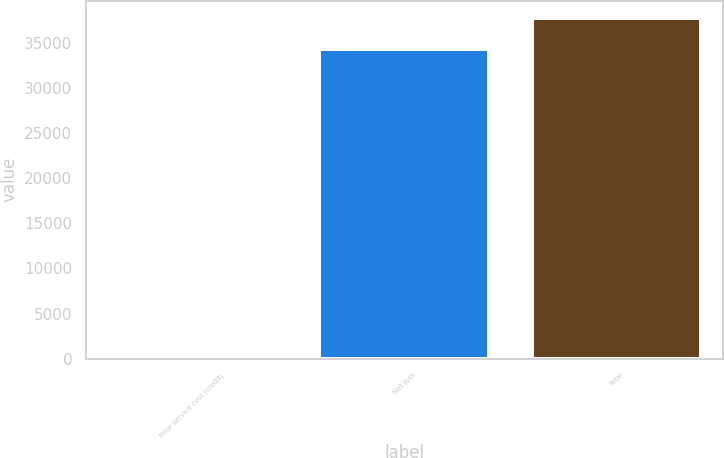<chart> <loc_0><loc_0><loc_500><loc_500><bar_chart><fcel>Prior service cost (credit)<fcel>Net loss<fcel>Total<nl><fcel>86<fcel>34337<fcel>37770.7<nl></chart> 